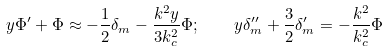<formula> <loc_0><loc_0><loc_500><loc_500>y \Phi ^ { \prime } + \Phi \approx - \frac { 1 } { 2 } \delta _ { m } - \frac { k ^ { 2 } y } { 3 k _ { c } ^ { 2 } } \Phi ; \quad y \delta _ { m } ^ { \prime \prime } + \frac { 3 } { 2 } \delta _ { m } ^ { \prime } = - \frac { k ^ { 2 } } { k _ { c } ^ { 2 } } \Phi</formula> 